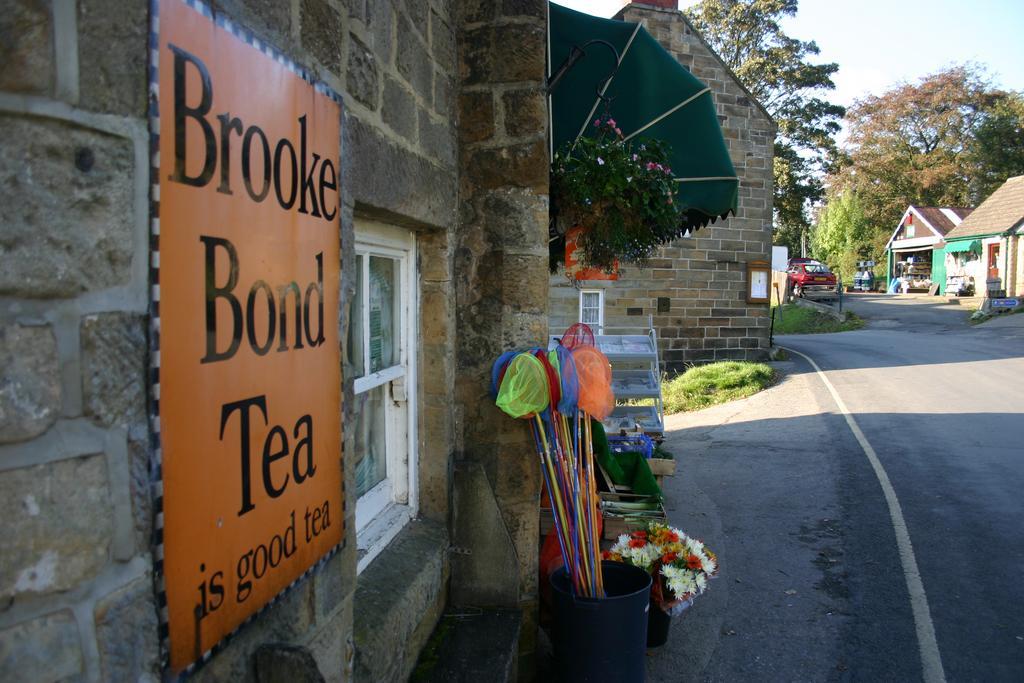Could you give a brief overview of what you see in this image? In this image, we can see a board on the wall and in the background, we can see sheds, trees, poles and some flower bouquets, nets, bins, a tent, a stand and some plants and we can see a vehicle on the road. 